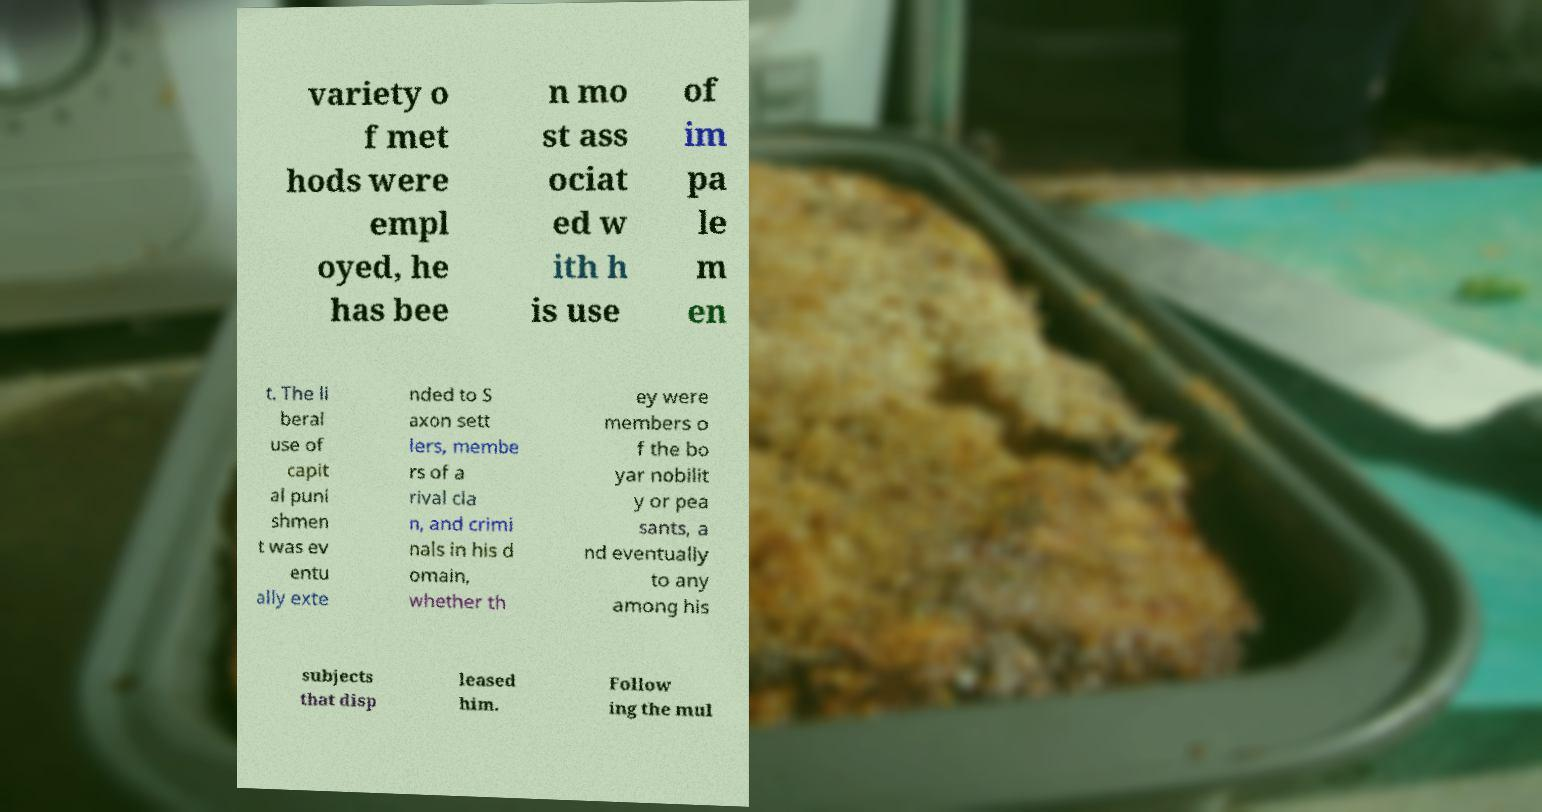I need the written content from this picture converted into text. Can you do that? variety o f met hods were empl oyed, he has bee n mo st ass ociat ed w ith h is use of im pa le m en t. The li beral use of capit al puni shmen t was ev entu ally exte nded to S axon sett lers, membe rs of a rival cla n, and crimi nals in his d omain, whether th ey were members o f the bo yar nobilit y or pea sants, a nd eventually to any among his subjects that disp leased him. Follow ing the mul 